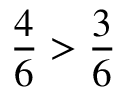Convert formula to latex. <formula><loc_0><loc_0><loc_500><loc_500>{ \frac { 4 } { 6 } } > { \frac { 3 } { 6 } }</formula> 